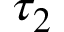<formula> <loc_0><loc_0><loc_500><loc_500>\tau _ { 2 }</formula> 